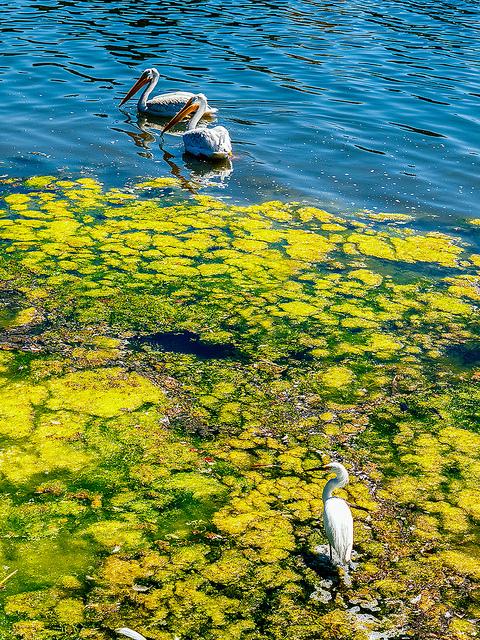What is the bird walking on?
Give a very brief answer. Plants. How many birds are in the picture?
Write a very short answer. 3. Is it daylight outside?
Short answer required. Yes. 